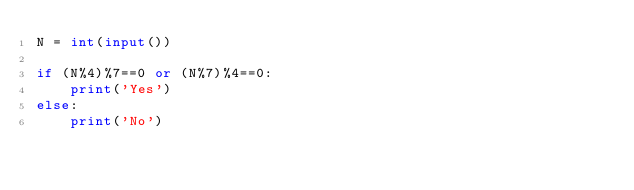Convert code to text. <code><loc_0><loc_0><loc_500><loc_500><_Python_>N = int(input())

if (N%4)%7==0 or (N%7)%4==0:
    print('Yes')
else:
    print('No')</code> 